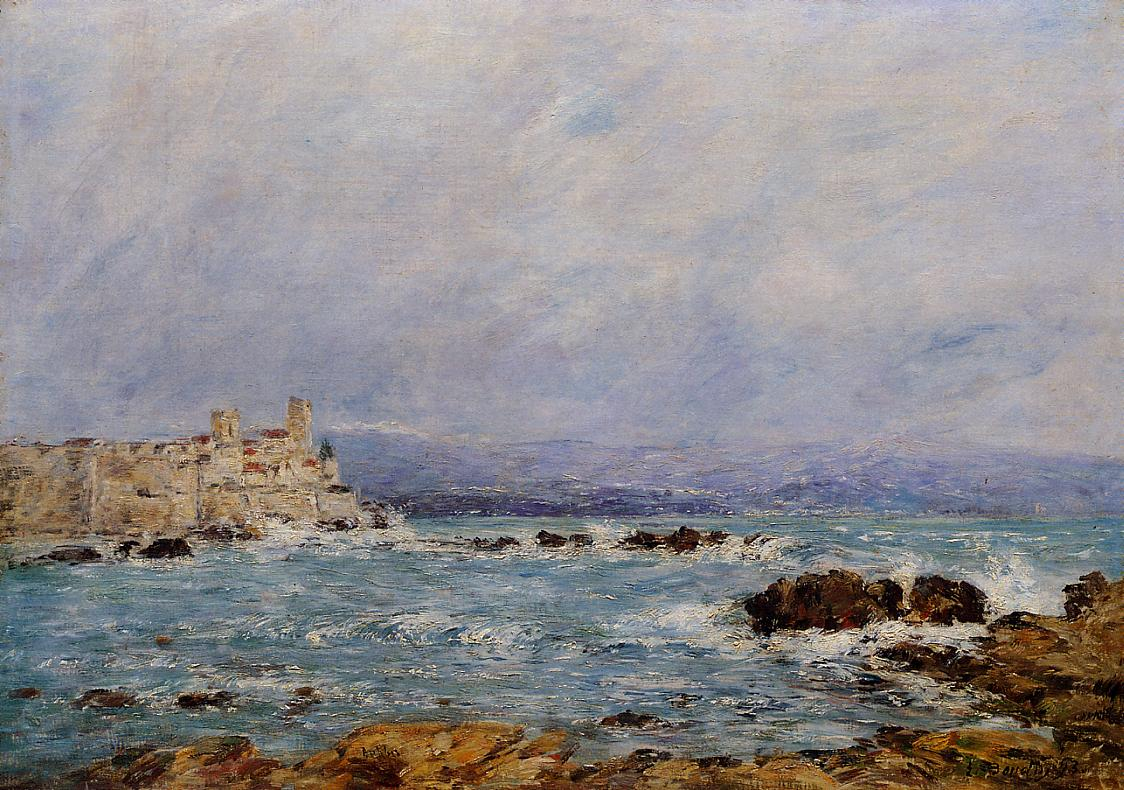What emotions does this painting evoke in you? The painting evokes a blend of serenity and grandeur. The tranquil sky and calm sea balance the rugged, imposing nature of the castle and the rocky coast. This juxtaposition of elements can inspire feelings of peaceful solitude, as well as awe for the timeless beauty of nature and historical architecture. 